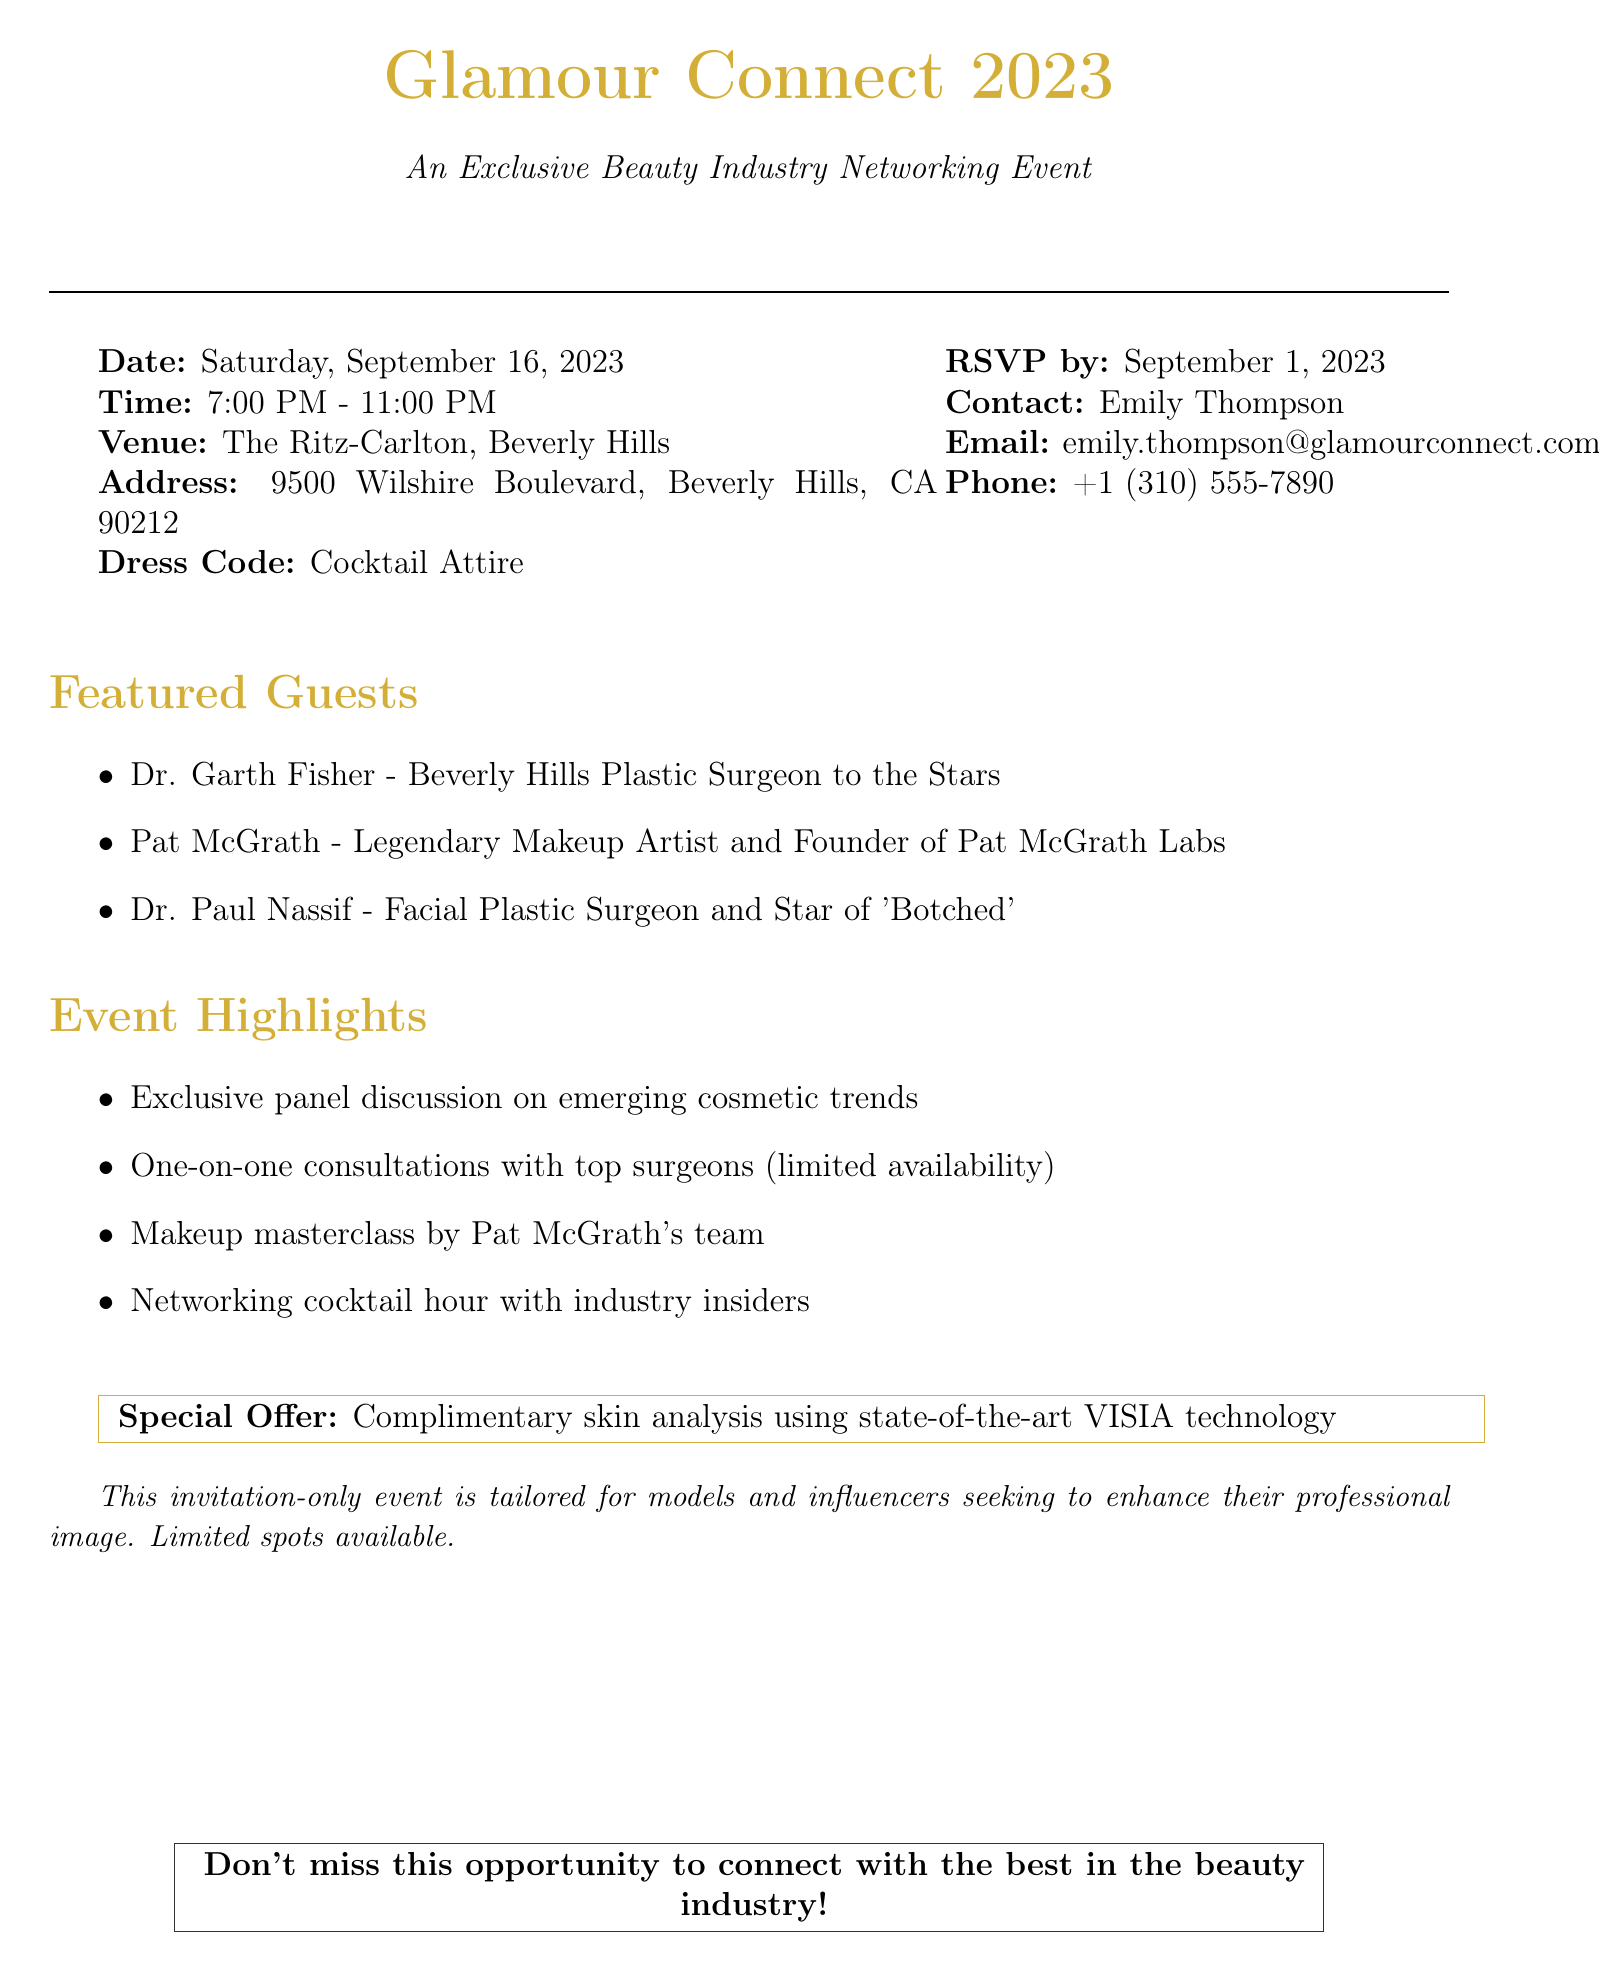What is the event name? The event name is stated at the top of the document.
Answer: Glamour Connect 2023 When does the event take place? The date of the event is mentioned clearly in the document.
Answer: Saturday, September 16, 2023 Who is the legendary makeup artist featured at the event? The featured guests section lists prominent individuals attending the event.
Answer: Pat McGrath What is the dress code for the event? The dress code is specifically stated in the document.
Answer: Cocktail Attire What special offer is available at the event? The document highlights a special offer related to the event.
Answer: Complimentary skin analysis using state-of-the-art VISIA technology What time does the event start? The starting time is listed under the event details in the document.
Answer: 7:00 PM How many featured guests are mentioned in the document? The number of featured guests can be determined by counting the list provided in the document.
Answer: 3 What does the event primarily target? The document provides a description of the audience for the event.
Answer: Models and influencers Who should be contacted for more information? The contact person and her details are listed in the document.
Answer: Emily Thompson 